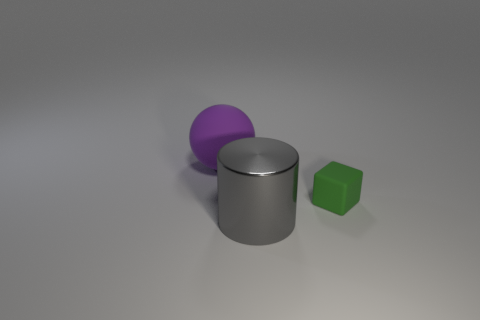Add 3 brown rubber cylinders. How many objects exist? 6 Subtract all blocks. How many objects are left? 2 Add 2 tiny green matte objects. How many tiny green matte objects exist? 3 Subtract 0 gray spheres. How many objects are left? 3 Subtract all large purple rubber things. Subtract all large gray cylinders. How many objects are left? 1 Add 2 small green blocks. How many small green blocks are left? 3 